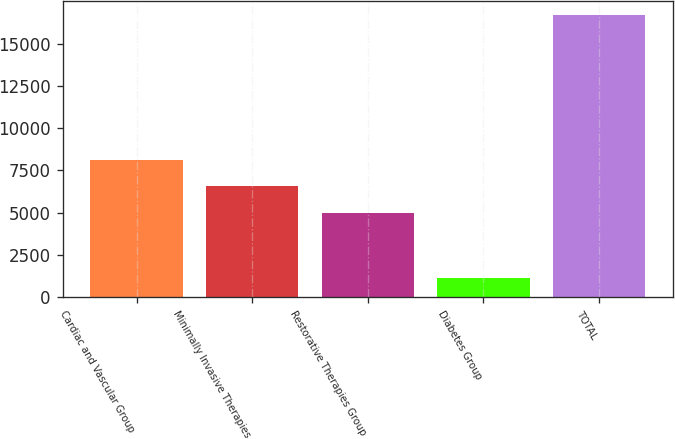Convert chart to OTSL. <chart><loc_0><loc_0><loc_500><loc_500><bar_chart><fcel>Cardiac and Vascular Group<fcel>Minimally Invasive Therapies<fcel>Restorative Therapies Group<fcel>Diabetes Group<fcel>TOTAL<nl><fcel>8115<fcel>6563.5<fcel>5012<fcel>1148<fcel>16663<nl></chart> 